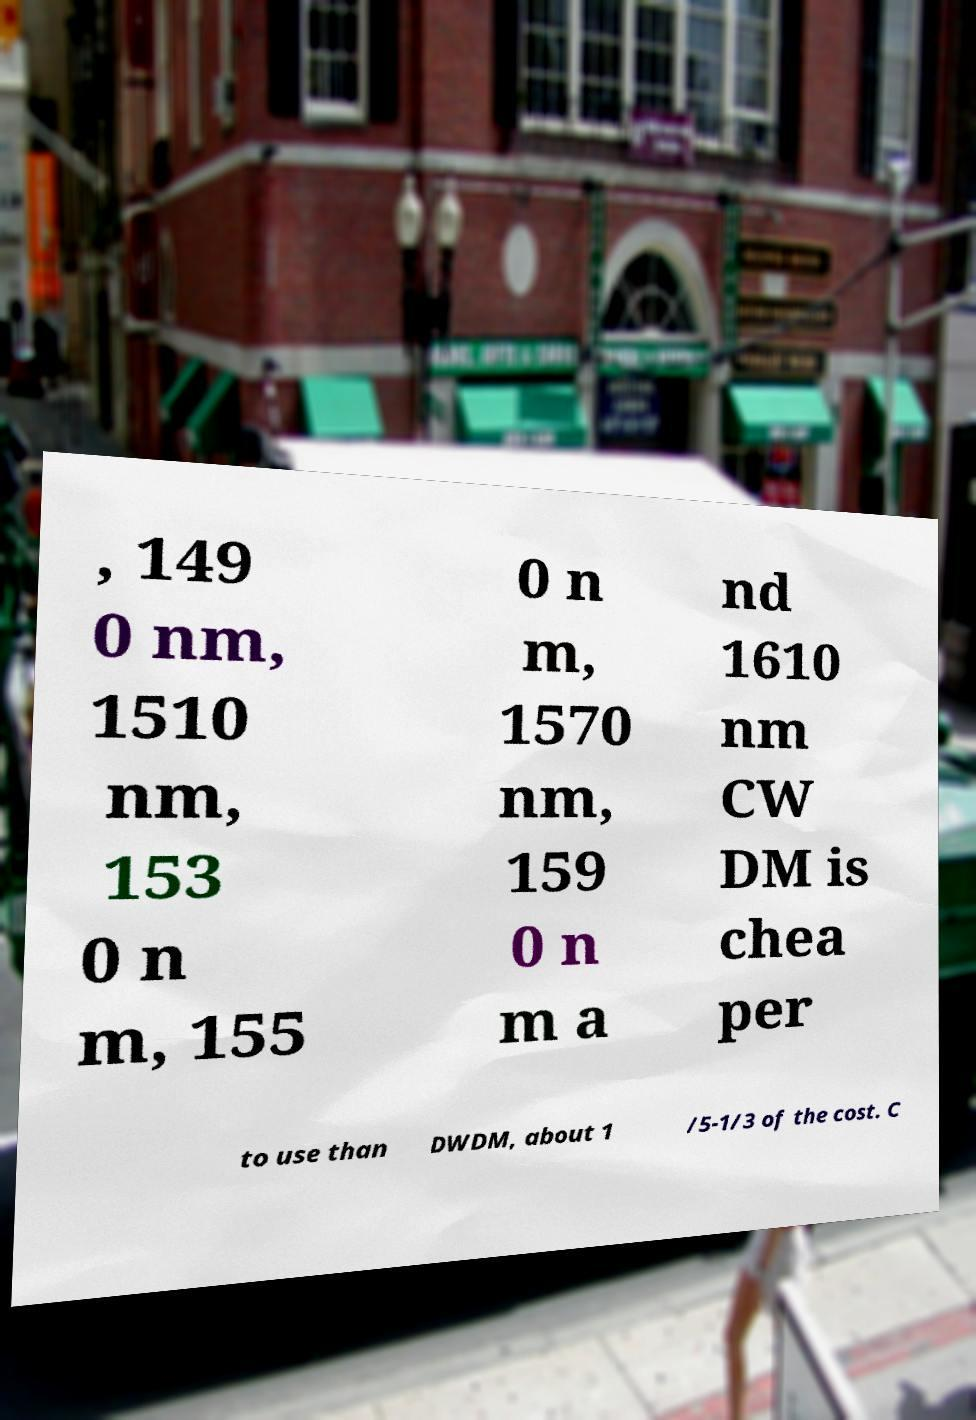Can you read and provide the text displayed in the image?This photo seems to have some interesting text. Can you extract and type it out for me? , 149 0 nm, 1510 nm, 153 0 n m, 155 0 n m, 1570 nm, 159 0 n m a nd 1610 nm CW DM is chea per to use than DWDM, about 1 /5-1/3 of the cost. C 